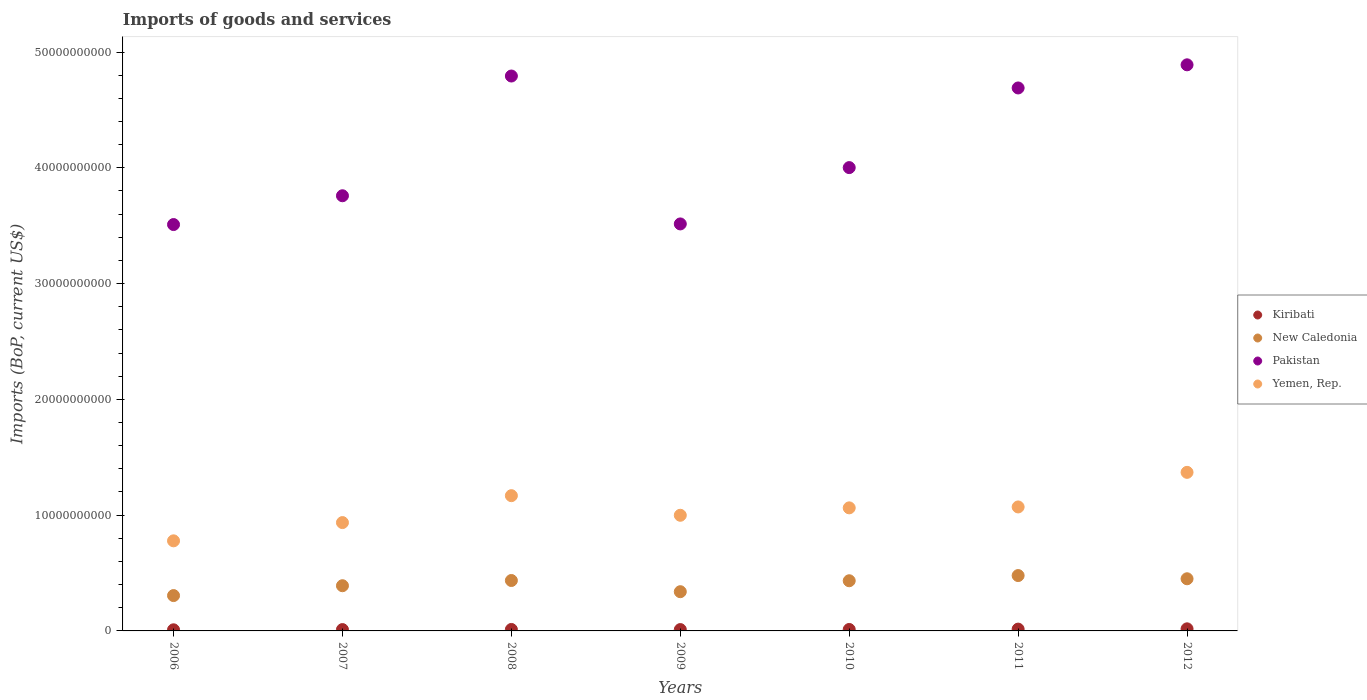Is the number of dotlines equal to the number of legend labels?
Your response must be concise. Yes. What is the amount spent on imports in Kiribati in 2009?
Provide a short and direct response. 1.16e+08. Across all years, what is the maximum amount spent on imports in Yemen, Rep.?
Provide a short and direct response. 1.37e+1. Across all years, what is the minimum amount spent on imports in New Caledonia?
Offer a terse response. 3.05e+09. What is the total amount spent on imports in Yemen, Rep. in the graph?
Your response must be concise. 7.38e+1. What is the difference between the amount spent on imports in New Caledonia in 2008 and that in 2011?
Your answer should be very brief. -4.27e+08. What is the difference between the amount spent on imports in New Caledonia in 2009 and the amount spent on imports in Kiribati in 2012?
Offer a very short reply. 3.21e+09. What is the average amount spent on imports in Pakistan per year?
Provide a succinct answer. 4.17e+1. In the year 2008, what is the difference between the amount spent on imports in Pakistan and amount spent on imports in Kiribati?
Keep it short and to the point. 4.78e+1. What is the ratio of the amount spent on imports in Pakistan in 2008 to that in 2009?
Your answer should be compact. 1.36. Is the difference between the amount spent on imports in Pakistan in 2006 and 2010 greater than the difference between the amount spent on imports in Kiribati in 2006 and 2010?
Provide a short and direct response. No. What is the difference between the highest and the second highest amount spent on imports in Kiribati?
Make the answer very short. 2.43e+07. What is the difference between the highest and the lowest amount spent on imports in Kiribati?
Make the answer very short. 8.41e+07. In how many years, is the amount spent on imports in Kiribati greater than the average amount spent on imports in Kiribati taken over all years?
Offer a terse response. 2. Does the amount spent on imports in Pakistan monotonically increase over the years?
Give a very brief answer. No. Is the amount spent on imports in Pakistan strictly less than the amount spent on imports in Yemen, Rep. over the years?
Your answer should be very brief. No. How many dotlines are there?
Make the answer very short. 4. How many years are there in the graph?
Your response must be concise. 7. Does the graph contain any zero values?
Provide a short and direct response. No. Where does the legend appear in the graph?
Your answer should be very brief. Center right. How many legend labels are there?
Your answer should be compact. 4. How are the legend labels stacked?
Provide a short and direct response. Vertical. What is the title of the graph?
Give a very brief answer. Imports of goods and services. Does "Lesotho" appear as one of the legend labels in the graph?
Your response must be concise. No. What is the label or title of the Y-axis?
Offer a very short reply. Imports (BoP, current US$). What is the Imports (BoP, current US$) in Kiribati in 2006?
Provide a succinct answer. 9.63e+07. What is the Imports (BoP, current US$) in New Caledonia in 2006?
Provide a succinct answer. 3.05e+09. What is the Imports (BoP, current US$) of Pakistan in 2006?
Ensure brevity in your answer.  3.51e+1. What is the Imports (BoP, current US$) of Yemen, Rep. in 2006?
Keep it short and to the point. 7.78e+09. What is the Imports (BoP, current US$) in Kiribati in 2007?
Your response must be concise. 1.16e+08. What is the Imports (BoP, current US$) in New Caledonia in 2007?
Provide a succinct answer. 3.90e+09. What is the Imports (BoP, current US$) of Pakistan in 2007?
Your answer should be compact. 3.76e+1. What is the Imports (BoP, current US$) of Yemen, Rep. in 2007?
Ensure brevity in your answer.  9.36e+09. What is the Imports (BoP, current US$) of Kiribati in 2008?
Provide a short and direct response. 1.26e+08. What is the Imports (BoP, current US$) of New Caledonia in 2008?
Provide a succinct answer. 4.35e+09. What is the Imports (BoP, current US$) in Pakistan in 2008?
Keep it short and to the point. 4.79e+1. What is the Imports (BoP, current US$) of Yemen, Rep. in 2008?
Keep it short and to the point. 1.17e+1. What is the Imports (BoP, current US$) of Kiribati in 2009?
Give a very brief answer. 1.16e+08. What is the Imports (BoP, current US$) in New Caledonia in 2009?
Keep it short and to the point. 3.39e+09. What is the Imports (BoP, current US$) of Pakistan in 2009?
Offer a very short reply. 3.52e+1. What is the Imports (BoP, current US$) in Yemen, Rep. in 2009?
Your response must be concise. 9.99e+09. What is the Imports (BoP, current US$) of Kiribati in 2010?
Offer a very short reply. 1.26e+08. What is the Imports (BoP, current US$) in New Caledonia in 2010?
Your answer should be compact. 4.33e+09. What is the Imports (BoP, current US$) of Pakistan in 2010?
Offer a terse response. 4.00e+1. What is the Imports (BoP, current US$) in Yemen, Rep. in 2010?
Offer a very short reply. 1.06e+1. What is the Imports (BoP, current US$) in Kiribati in 2011?
Provide a succinct answer. 1.56e+08. What is the Imports (BoP, current US$) of New Caledonia in 2011?
Make the answer very short. 4.78e+09. What is the Imports (BoP, current US$) in Pakistan in 2011?
Offer a very short reply. 4.69e+1. What is the Imports (BoP, current US$) of Yemen, Rep. in 2011?
Provide a short and direct response. 1.07e+1. What is the Imports (BoP, current US$) in Kiribati in 2012?
Ensure brevity in your answer.  1.80e+08. What is the Imports (BoP, current US$) of New Caledonia in 2012?
Your answer should be compact. 4.50e+09. What is the Imports (BoP, current US$) of Pakistan in 2012?
Your answer should be compact. 4.89e+1. What is the Imports (BoP, current US$) in Yemen, Rep. in 2012?
Your response must be concise. 1.37e+1. Across all years, what is the maximum Imports (BoP, current US$) of Kiribati?
Your answer should be compact. 1.80e+08. Across all years, what is the maximum Imports (BoP, current US$) of New Caledonia?
Ensure brevity in your answer.  4.78e+09. Across all years, what is the maximum Imports (BoP, current US$) of Pakistan?
Keep it short and to the point. 4.89e+1. Across all years, what is the maximum Imports (BoP, current US$) of Yemen, Rep.?
Offer a terse response. 1.37e+1. Across all years, what is the minimum Imports (BoP, current US$) in Kiribati?
Keep it short and to the point. 9.63e+07. Across all years, what is the minimum Imports (BoP, current US$) in New Caledonia?
Give a very brief answer. 3.05e+09. Across all years, what is the minimum Imports (BoP, current US$) of Pakistan?
Your answer should be compact. 3.51e+1. Across all years, what is the minimum Imports (BoP, current US$) in Yemen, Rep.?
Your answer should be very brief. 7.78e+09. What is the total Imports (BoP, current US$) of Kiribati in the graph?
Provide a succinct answer. 9.16e+08. What is the total Imports (BoP, current US$) of New Caledonia in the graph?
Give a very brief answer. 2.83e+1. What is the total Imports (BoP, current US$) of Pakistan in the graph?
Keep it short and to the point. 2.92e+11. What is the total Imports (BoP, current US$) of Yemen, Rep. in the graph?
Make the answer very short. 7.38e+1. What is the difference between the Imports (BoP, current US$) in Kiribati in 2006 and that in 2007?
Provide a succinct answer. -1.95e+07. What is the difference between the Imports (BoP, current US$) of New Caledonia in 2006 and that in 2007?
Offer a very short reply. -8.51e+08. What is the difference between the Imports (BoP, current US$) of Pakistan in 2006 and that in 2007?
Provide a short and direct response. -2.49e+09. What is the difference between the Imports (BoP, current US$) of Yemen, Rep. in 2006 and that in 2007?
Provide a short and direct response. -1.58e+09. What is the difference between the Imports (BoP, current US$) in Kiribati in 2006 and that in 2008?
Provide a succinct answer. -2.96e+07. What is the difference between the Imports (BoP, current US$) of New Caledonia in 2006 and that in 2008?
Offer a terse response. -1.30e+09. What is the difference between the Imports (BoP, current US$) of Pakistan in 2006 and that in 2008?
Provide a succinct answer. -1.28e+1. What is the difference between the Imports (BoP, current US$) of Yemen, Rep. in 2006 and that in 2008?
Your response must be concise. -3.90e+09. What is the difference between the Imports (BoP, current US$) of Kiribati in 2006 and that in 2009?
Offer a very short reply. -1.99e+07. What is the difference between the Imports (BoP, current US$) of New Caledonia in 2006 and that in 2009?
Offer a very short reply. -3.35e+08. What is the difference between the Imports (BoP, current US$) of Pakistan in 2006 and that in 2009?
Provide a short and direct response. -5.40e+07. What is the difference between the Imports (BoP, current US$) in Yemen, Rep. in 2006 and that in 2009?
Your response must be concise. -2.21e+09. What is the difference between the Imports (BoP, current US$) in Kiribati in 2006 and that in 2010?
Keep it short and to the point. -2.94e+07. What is the difference between the Imports (BoP, current US$) in New Caledonia in 2006 and that in 2010?
Offer a terse response. -1.28e+09. What is the difference between the Imports (BoP, current US$) in Pakistan in 2006 and that in 2010?
Keep it short and to the point. -4.92e+09. What is the difference between the Imports (BoP, current US$) of Yemen, Rep. in 2006 and that in 2010?
Your answer should be very brief. -2.85e+09. What is the difference between the Imports (BoP, current US$) in Kiribati in 2006 and that in 2011?
Provide a short and direct response. -5.98e+07. What is the difference between the Imports (BoP, current US$) in New Caledonia in 2006 and that in 2011?
Provide a short and direct response. -1.73e+09. What is the difference between the Imports (BoP, current US$) in Pakistan in 2006 and that in 2011?
Give a very brief answer. -1.18e+1. What is the difference between the Imports (BoP, current US$) of Yemen, Rep. in 2006 and that in 2011?
Your answer should be compact. -2.93e+09. What is the difference between the Imports (BoP, current US$) of Kiribati in 2006 and that in 2012?
Make the answer very short. -8.41e+07. What is the difference between the Imports (BoP, current US$) of New Caledonia in 2006 and that in 2012?
Ensure brevity in your answer.  -1.45e+09. What is the difference between the Imports (BoP, current US$) in Pakistan in 2006 and that in 2012?
Ensure brevity in your answer.  -1.38e+1. What is the difference between the Imports (BoP, current US$) in Yemen, Rep. in 2006 and that in 2012?
Offer a terse response. -5.91e+09. What is the difference between the Imports (BoP, current US$) in Kiribati in 2007 and that in 2008?
Offer a terse response. -1.01e+07. What is the difference between the Imports (BoP, current US$) in New Caledonia in 2007 and that in 2008?
Provide a short and direct response. -4.51e+08. What is the difference between the Imports (BoP, current US$) in Pakistan in 2007 and that in 2008?
Keep it short and to the point. -1.03e+1. What is the difference between the Imports (BoP, current US$) in Yemen, Rep. in 2007 and that in 2008?
Make the answer very short. -2.32e+09. What is the difference between the Imports (BoP, current US$) of Kiribati in 2007 and that in 2009?
Offer a terse response. -4.05e+05. What is the difference between the Imports (BoP, current US$) of New Caledonia in 2007 and that in 2009?
Give a very brief answer. 5.16e+08. What is the difference between the Imports (BoP, current US$) in Pakistan in 2007 and that in 2009?
Ensure brevity in your answer.  2.43e+09. What is the difference between the Imports (BoP, current US$) of Yemen, Rep. in 2007 and that in 2009?
Offer a terse response. -6.31e+08. What is the difference between the Imports (BoP, current US$) of Kiribati in 2007 and that in 2010?
Provide a succinct answer. -9.92e+06. What is the difference between the Imports (BoP, current US$) of New Caledonia in 2007 and that in 2010?
Your answer should be compact. -4.29e+08. What is the difference between the Imports (BoP, current US$) in Pakistan in 2007 and that in 2010?
Your answer should be very brief. -2.43e+09. What is the difference between the Imports (BoP, current US$) of Yemen, Rep. in 2007 and that in 2010?
Your answer should be very brief. -1.27e+09. What is the difference between the Imports (BoP, current US$) in Kiribati in 2007 and that in 2011?
Provide a short and direct response. -4.03e+07. What is the difference between the Imports (BoP, current US$) of New Caledonia in 2007 and that in 2011?
Offer a very short reply. -8.78e+08. What is the difference between the Imports (BoP, current US$) in Pakistan in 2007 and that in 2011?
Offer a terse response. -9.31e+09. What is the difference between the Imports (BoP, current US$) in Yemen, Rep. in 2007 and that in 2011?
Your answer should be compact. -1.35e+09. What is the difference between the Imports (BoP, current US$) in Kiribati in 2007 and that in 2012?
Give a very brief answer. -6.46e+07. What is the difference between the Imports (BoP, current US$) in New Caledonia in 2007 and that in 2012?
Provide a short and direct response. -6.01e+08. What is the difference between the Imports (BoP, current US$) of Pakistan in 2007 and that in 2012?
Offer a very short reply. -1.13e+1. What is the difference between the Imports (BoP, current US$) of Yemen, Rep. in 2007 and that in 2012?
Provide a short and direct response. -4.34e+09. What is the difference between the Imports (BoP, current US$) of Kiribati in 2008 and that in 2009?
Your answer should be very brief. 9.73e+06. What is the difference between the Imports (BoP, current US$) in New Caledonia in 2008 and that in 2009?
Offer a terse response. 9.67e+08. What is the difference between the Imports (BoP, current US$) in Pakistan in 2008 and that in 2009?
Provide a succinct answer. 1.28e+1. What is the difference between the Imports (BoP, current US$) in Yemen, Rep. in 2008 and that in 2009?
Offer a terse response. 1.69e+09. What is the difference between the Imports (BoP, current US$) of Kiribati in 2008 and that in 2010?
Offer a terse response. 2.10e+05. What is the difference between the Imports (BoP, current US$) of New Caledonia in 2008 and that in 2010?
Provide a short and direct response. 2.13e+07. What is the difference between the Imports (BoP, current US$) in Pakistan in 2008 and that in 2010?
Keep it short and to the point. 7.91e+09. What is the difference between the Imports (BoP, current US$) in Yemen, Rep. in 2008 and that in 2010?
Your response must be concise. 1.05e+09. What is the difference between the Imports (BoP, current US$) in Kiribati in 2008 and that in 2011?
Provide a succinct answer. -3.02e+07. What is the difference between the Imports (BoP, current US$) of New Caledonia in 2008 and that in 2011?
Your answer should be compact. -4.27e+08. What is the difference between the Imports (BoP, current US$) of Pakistan in 2008 and that in 2011?
Your answer should be compact. 1.03e+09. What is the difference between the Imports (BoP, current US$) of Yemen, Rep. in 2008 and that in 2011?
Your answer should be compact. 9.74e+08. What is the difference between the Imports (BoP, current US$) of Kiribati in 2008 and that in 2012?
Offer a terse response. -5.44e+07. What is the difference between the Imports (BoP, current US$) of New Caledonia in 2008 and that in 2012?
Ensure brevity in your answer.  -1.50e+08. What is the difference between the Imports (BoP, current US$) in Pakistan in 2008 and that in 2012?
Your answer should be compact. -9.67e+08. What is the difference between the Imports (BoP, current US$) in Yemen, Rep. in 2008 and that in 2012?
Provide a succinct answer. -2.01e+09. What is the difference between the Imports (BoP, current US$) of Kiribati in 2009 and that in 2010?
Ensure brevity in your answer.  -9.52e+06. What is the difference between the Imports (BoP, current US$) in New Caledonia in 2009 and that in 2010?
Ensure brevity in your answer.  -9.46e+08. What is the difference between the Imports (BoP, current US$) in Pakistan in 2009 and that in 2010?
Give a very brief answer. -4.86e+09. What is the difference between the Imports (BoP, current US$) in Yemen, Rep. in 2009 and that in 2010?
Your response must be concise. -6.41e+08. What is the difference between the Imports (BoP, current US$) in Kiribati in 2009 and that in 2011?
Offer a very short reply. -3.99e+07. What is the difference between the Imports (BoP, current US$) in New Caledonia in 2009 and that in 2011?
Ensure brevity in your answer.  -1.39e+09. What is the difference between the Imports (BoP, current US$) in Pakistan in 2009 and that in 2011?
Give a very brief answer. -1.17e+1. What is the difference between the Imports (BoP, current US$) of Yemen, Rep. in 2009 and that in 2011?
Give a very brief answer. -7.19e+08. What is the difference between the Imports (BoP, current US$) in Kiribati in 2009 and that in 2012?
Give a very brief answer. -6.42e+07. What is the difference between the Imports (BoP, current US$) of New Caledonia in 2009 and that in 2012?
Your answer should be compact. -1.12e+09. What is the difference between the Imports (BoP, current US$) in Pakistan in 2009 and that in 2012?
Ensure brevity in your answer.  -1.37e+1. What is the difference between the Imports (BoP, current US$) in Yemen, Rep. in 2009 and that in 2012?
Your answer should be very brief. -3.71e+09. What is the difference between the Imports (BoP, current US$) in Kiribati in 2010 and that in 2011?
Your answer should be compact. -3.04e+07. What is the difference between the Imports (BoP, current US$) of New Caledonia in 2010 and that in 2011?
Ensure brevity in your answer.  -4.48e+08. What is the difference between the Imports (BoP, current US$) in Pakistan in 2010 and that in 2011?
Make the answer very short. -6.88e+09. What is the difference between the Imports (BoP, current US$) in Yemen, Rep. in 2010 and that in 2011?
Offer a terse response. -7.88e+07. What is the difference between the Imports (BoP, current US$) in Kiribati in 2010 and that in 2012?
Provide a succinct answer. -5.46e+07. What is the difference between the Imports (BoP, current US$) in New Caledonia in 2010 and that in 2012?
Provide a succinct answer. -1.71e+08. What is the difference between the Imports (BoP, current US$) in Pakistan in 2010 and that in 2012?
Keep it short and to the point. -8.88e+09. What is the difference between the Imports (BoP, current US$) in Yemen, Rep. in 2010 and that in 2012?
Offer a very short reply. -3.07e+09. What is the difference between the Imports (BoP, current US$) in Kiribati in 2011 and that in 2012?
Your answer should be compact. -2.43e+07. What is the difference between the Imports (BoP, current US$) in New Caledonia in 2011 and that in 2012?
Your answer should be very brief. 2.77e+08. What is the difference between the Imports (BoP, current US$) of Pakistan in 2011 and that in 2012?
Offer a very short reply. -2.00e+09. What is the difference between the Imports (BoP, current US$) in Yemen, Rep. in 2011 and that in 2012?
Offer a very short reply. -2.99e+09. What is the difference between the Imports (BoP, current US$) in Kiribati in 2006 and the Imports (BoP, current US$) in New Caledonia in 2007?
Ensure brevity in your answer.  -3.81e+09. What is the difference between the Imports (BoP, current US$) in Kiribati in 2006 and the Imports (BoP, current US$) in Pakistan in 2007?
Ensure brevity in your answer.  -3.75e+1. What is the difference between the Imports (BoP, current US$) in Kiribati in 2006 and the Imports (BoP, current US$) in Yemen, Rep. in 2007?
Provide a succinct answer. -9.26e+09. What is the difference between the Imports (BoP, current US$) of New Caledonia in 2006 and the Imports (BoP, current US$) of Pakistan in 2007?
Give a very brief answer. -3.45e+1. What is the difference between the Imports (BoP, current US$) of New Caledonia in 2006 and the Imports (BoP, current US$) of Yemen, Rep. in 2007?
Give a very brief answer. -6.30e+09. What is the difference between the Imports (BoP, current US$) of Pakistan in 2006 and the Imports (BoP, current US$) of Yemen, Rep. in 2007?
Offer a very short reply. 2.57e+1. What is the difference between the Imports (BoP, current US$) of Kiribati in 2006 and the Imports (BoP, current US$) of New Caledonia in 2008?
Your response must be concise. -4.26e+09. What is the difference between the Imports (BoP, current US$) in Kiribati in 2006 and the Imports (BoP, current US$) in Pakistan in 2008?
Provide a succinct answer. -4.78e+1. What is the difference between the Imports (BoP, current US$) of Kiribati in 2006 and the Imports (BoP, current US$) of Yemen, Rep. in 2008?
Give a very brief answer. -1.16e+1. What is the difference between the Imports (BoP, current US$) of New Caledonia in 2006 and the Imports (BoP, current US$) of Pakistan in 2008?
Provide a short and direct response. -4.49e+1. What is the difference between the Imports (BoP, current US$) of New Caledonia in 2006 and the Imports (BoP, current US$) of Yemen, Rep. in 2008?
Offer a very short reply. -8.63e+09. What is the difference between the Imports (BoP, current US$) of Pakistan in 2006 and the Imports (BoP, current US$) of Yemen, Rep. in 2008?
Provide a succinct answer. 2.34e+1. What is the difference between the Imports (BoP, current US$) in Kiribati in 2006 and the Imports (BoP, current US$) in New Caledonia in 2009?
Your answer should be very brief. -3.29e+09. What is the difference between the Imports (BoP, current US$) in Kiribati in 2006 and the Imports (BoP, current US$) in Pakistan in 2009?
Give a very brief answer. -3.51e+1. What is the difference between the Imports (BoP, current US$) of Kiribati in 2006 and the Imports (BoP, current US$) of Yemen, Rep. in 2009?
Your answer should be compact. -9.89e+09. What is the difference between the Imports (BoP, current US$) in New Caledonia in 2006 and the Imports (BoP, current US$) in Pakistan in 2009?
Make the answer very short. -3.21e+1. What is the difference between the Imports (BoP, current US$) of New Caledonia in 2006 and the Imports (BoP, current US$) of Yemen, Rep. in 2009?
Your answer should be very brief. -6.94e+09. What is the difference between the Imports (BoP, current US$) of Pakistan in 2006 and the Imports (BoP, current US$) of Yemen, Rep. in 2009?
Keep it short and to the point. 2.51e+1. What is the difference between the Imports (BoP, current US$) in Kiribati in 2006 and the Imports (BoP, current US$) in New Caledonia in 2010?
Give a very brief answer. -4.24e+09. What is the difference between the Imports (BoP, current US$) of Kiribati in 2006 and the Imports (BoP, current US$) of Pakistan in 2010?
Provide a succinct answer. -3.99e+1. What is the difference between the Imports (BoP, current US$) of Kiribati in 2006 and the Imports (BoP, current US$) of Yemen, Rep. in 2010?
Your response must be concise. -1.05e+1. What is the difference between the Imports (BoP, current US$) in New Caledonia in 2006 and the Imports (BoP, current US$) in Pakistan in 2010?
Your response must be concise. -3.70e+1. What is the difference between the Imports (BoP, current US$) in New Caledonia in 2006 and the Imports (BoP, current US$) in Yemen, Rep. in 2010?
Offer a very short reply. -7.58e+09. What is the difference between the Imports (BoP, current US$) in Pakistan in 2006 and the Imports (BoP, current US$) in Yemen, Rep. in 2010?
Ensure brevity in your answer.  2.45e+1. What is the difference between the Imports (BoP, current US$) of Kiribati in 2006 and the Imports (BoP, current US$) of New Caledonia in 2011?
Offer a terse response. -4.69e+09. What is the difference between the Imports (BoP, current US$) in Kiribati in 2006 and the Imports (BoP, current US$) in Pakistan in 2011?
Offer a terse response. -4.68e+1. What is the difference between the Imports (BoP, current US$) in Kiribati in 2006 and the Imports (BoP, current US$) in Yemen, Rep. in 2011?
Offer a very short reply. -1.06e+1. What is the difference between the Imports (BoP, current US$) in New Caledonia in 2006 and the Imports (BoP, current US$) in Pakistan in 2011?
Provide a short and direct response. -4.38e+1. What is the difference between the Imports (BoP, current US$) of New Caledonia in 2006 and the Imports (BoP, current US$) of Yemen, Rep. in 2011?
Offer a very short reply. -7.66e+09. What is the difference between the Imports (BoP, current US$) in Pakistan in 2006 and the Imports (BoP, current US$) in Yemen, Rep. in 2011?
Keep it short and to the point. 2.44e+1. What is the difference between the Imports (BoP, current US$) in Kiribati in 2006 and the Imports (BoP, current US$) in New Caledonia in 2012?
Offer a terse response. -4.41e+09. What is the difference between the Imports (BoP, current US$) in Kiribati in 2006 and the Imports (BoP, current US$) in Pakistan in 2012?
Keep it short and to the point. -4.88e+1. What is the difference between the Imports (BoP, current US$) of Kiribati in 2006 and the Imports (BoP, current US$) of Yemen, Rep. in 2012?
Your answer should be very brief. -1.36e+1. What is the difference between the Imports (BoP, current US$) in New Caledonia in 2006 and the Imports (BoP, current US$) in Pakistan in 2012?
Offer a terse response. -4.58e+1. What is the difference between the Imports (BoP, current US$) of New Caledonia in 2006 and the Imports (BoP, current US$) of Yemen, Rep. in 2012?
Give a very brief answer. -1.06e+1. What is the difference between the Imports (BoP, current US$) of Pakistan in 2006 and the Imports (BoP, current US$) of Yemen, Rep. in 2012?
Your response must be concise. 2.14e+1. What is the difference between the Imports (BoP, current US$) of Kiribati in 2007 and the Imports (BoP, current US$) of New Caledonia in 2008?
Provide a succinct answer. -4.24e+09. What is the difference between the Imports (BoP, current US$) in Kiribati in 2007 and the Imports (BoP, current US$) in Pakistan in 2008?
Provide a succinct answer. -4.78e+1. What is the difference between the Imports (BoP, current US$) in Kiribati in 2007 and the Imports (BoP, current US$) in Yemen, Rep. in 2008?
Ensure brevity in your answer.  -1.16e+1. What is the difference between the Imports (BoP, current US$) of New Caledonia in 2007 and the Imports (BoP, current US$) of Pakistan in 2008?
Keep it short and to the point. -4.40e+1. What is the difference between the Imports (BoP, current US$) in New Caledonia in 2007 and the Imports (BoP, current US$) in Yemen, Rep. in 2008?
Provide a short and direct response. -7.78e+09. What is the difference between the Imports (BoP, current US$) of Pakistan in 2007 and the Imports (BoP, current US$) of Yemen, Rep. in 2008?
Provide a succinct answer. 2.59e+1. What is the difference between the Imports (BoP, current US$) in Kiribati in 2007 and the Imports (BoP, current US$) in New Caledonia in 2009?
Provide a succinct answer. -3.27e+09. What is the difference between the Imports (BoP, current US$) of Kiribati in 2007 and the Imports (BoP, current US$) of Pakistan in 2009?
Your answer should be compact. -3.50e+1. What is the difference between the Imports (BoP, current US$) in Kiribati in 2007 and the Imports (BoP, current US$) in Yemen, Rep. in 2009?
Your answer should be compact. -9.87e+09. What is the difference between the Imports (BoP, current US$) in New Caledonia in 2007 and the Imports (BoP, current US$) in Pakistan in 2009?
Your answer should be compact. -3.12e+1. What is the difference between the Imports (BoP, current US$) of New Caledonia in 2007 and the Imports (BoP, current US$) of Yemen, Rep. in 2009?
Offer a very short reply. -6.08e+09. What is the difference between the Imports (BoP, current US$) in Pakistan in 2007 and the Imports (BoP, current US$) in Yemen, Rep. in 2009?
Your response must be concise. 2.76e+1. What is the difference between the Imports (BoP, current US$) of Kiribati in 2007 and the Imports (BoP, current US$) of New Caledonia in 2010?
Provide a short and direct response. -4.22e+09. What is the difference between the Imports (BoP, current US$) in Kiribati in 2007 and the Imports (BoP, current US$) in Pakistan in 2010?
Your answer should be very brief. -3.99e+1. What is the difference between the Imports (BoP, current US$) of Kiribati in 2007 and the Imports (BoP, current US$) of Yemen, Rep. in 2010?
Your answer should be very brief. -1.05e+1. What is the difference between the Imports (BoP, current US$) of New Caledonia in 2007 and the Imports (BoP, current US$) of Pakistan in 2010?
Offer a terse response. -3.61e+1. What is the difference between the Imports (BoP, current US$) in New Caledonia in 2007 and the Imports (BoP, current US$) in Yemen, Rep. in 2010?
Provide a short and direct response. -6.73e+09. What is the difference between the Imports (BoP, current US$) of Pakistan in 2007 and the Imports (BoP, current US$) of Yemen, Rep. in 2010?
Make the answer very short. 2.70e+1. What is the difference between the Imports (BoP, current US$) in Kiribati in 2007 and the Imports (BoP, current US$) in New Caledonia in 2011?
Your answer should be very brief. -4.67e+09. What is the difference between the Imports (BoP, current US$) of Kiribati in 2007 and the Imports (BoP, current US$) of Pakistan in 2011?
Provide a succinct answer. -4.68e+1. What is the difference between the Imports (BoP, current US$) in Kiribati in 2007 and the Imports (BoP, current US$) in Yemen, Rep. in 2011?
Your answer should be very brief. -1.06e+1. What is the difference between the Imports (BoP, current US$) of New Caledonia in 2007 and the Imports (BoP, current US$) of Pakistan in 2011?
Your answer should be very brief. -4.30e+1. What is the difference between the Imports (BoP, current US$) in New Caledonia in 2007 and the Imports (BoP, current US$) in Yemen, Rep. in 2011?
Give a very brief answer. -6.80e+09. What is the difference between the Imports (BoP, current US$) in Pakistan in 2007 and the Imports (BoP, current US$) in Yemen, Rep. in 2011?
Provide a short and direct response. 2.69e+1. What is the difference between the Imports (BoP, current US$) of Kiribati in 2007 and the Imports (BoP, current US$) of New Caledonia in 2012?
Ensure brevity in your answer.  -4.39e+09. What is the difference between the Imports (BoP, current US$) in Kiribati in 2007 and the Imports (BoP, current US$) in Pakistan in 2012?
Provide a succinct answer. -4.88e+1. What is the difference between the Imports (BoP, current US$) of Kiribati in 2007 and the Imports (BoP, current US$) of Yemen, Rep. in 2012?
Your answer should be compact. -1.36e+1. What is the difference between the Imports (BoP, current US$) in New Caledonia in 2007 and the Imports (BoP, current US$) in Pakistan in 2012?
Give a very brief answer. -4.50e+1. What is the difference between the Imports (BoP, current US$) in New Caledonia in 2007 and the Imports (BoP, current US$) in Yemen, Rep. in 2012?
Provide a succinct answer. -9.79e+09. What is the difference between the Imports (BoP, current US$) in Pakistan in 2007 and the Imports (BoP, current US$) in Yemen, Rep. in 2012?
Give a very brief answer. 2.39e+1. What is the difference between the Imports (BoP, current US$) in Kiribati in 2008 and the Imports (BoP, current US$) in New Caledonia in 2009?
Keep it short and to the point. -3.26e+09. What is the difference between the Imports (BoP, current US$) of Kiribati in 2008 and the Imports (BoP, current US$) of Pakistan in 2009?
Your response must be concise. -3.50e+1. What is the difference between the Imports (BoP, current US$) of Kiribati in 2008 and the Imports (BoP, current US$) of Yemen, Rep. in 2009?
Ensure brevity in your answer.  -9.86e+09. What is the difference between the Imports (BoP, current US$) of New Caledonia in 2008 and the Imports (BoP, current US$) of Pakistan in 2009?
Ensure brevity in your answer.  -3.08e+1. What is the difference between the Imports (BoP, current US$) of New Caledonia in 2008 and the Imports (BoP, current US$) of Yemen, Rep. in 2009?
Your answer should be compact. -5.63e+09. What is the difference between the Imports (BoP, current US$) of Pakistan in 2008 and the Imports (BoP, current US$) of Yemen, Rep. in 2009?
Keep it short and to the point. 3.79e+1. What is the difference between the Imports (BoP, current US$) in Kiribati in 2008 and the Imports (BoP, current US$) in New Caledonia in 2010?
Your answer should be compact. -4.21e+09. What is the difference between the Imports (BoP, current US$) of Kiribati in 2008 and the Imports (BoP, current US$) of Pakistan in 2010?
Ensure brevity in your answer.  -3.99e+1. What is the difference between the Imports (BoP, current US$) in Kiribati in 2008 and the Imports (BoP, current US$) in Yemen, Rep. in 2010?
Ensure brevity in your answer.  -1.05e+1. What is the difference between the Imports (BoP, current US$) in New Caledonia in 2008 and the Imports (BoP, current US$) in Pakistan in 2010?
Your answer should be compact. -3.57e+1. What is the difference between the Imports (BoP, current US$) of New Caledonia in 2008 and the Imports (BoP, current US$) of Yemen, Rep. in 2010?
Make the answer very short. -6.27e+09. What is the difference between the Imports (BoP, current US$) of Pakistan in 2008 and the Imports (BoP, current US$) of Yemen, Rep. in 2010?
Offer a terse response. 3.73e+1. What is the difference between the Imports (BoP, current US$) of Kiribati in 2008 and the Imports (BoP, current US$) of New Caledonia in 2011?
Keep it short and to the point. -4.66e+09. What is the difference between the Imports (BoP, current US$) in Kiribati in 2008 and the Imports (BoP, current US$) in Pakistan in 2011?
Your answer should be very brief. -4.68e+1. What is the difference between the Imports (BoP, current US$) of Kiribati in 2008 and the Imports (BoP, current US$) of Yemen, Rep. in 2011?
Your answer should be compact. -1.06e+1. What is the difference between the Imports (BoP, current US$) of New Caledonia in 2008 and the Imports (BoP, current US$) of Pakistan in 2011?
Provide a succinct answer. -4.25e+1. What is the difference between the Imports (BoP, current US$) of New Caledonia in 2008 and the Imports (BoP, current US$) of Yemen, Rep. in 2011?
Your response must be concise. -6.35e+09. What is the difference between the Imports (BoP, current US$) in Pakistan in 2008 and the Imports (BoP, current US$) in Yemen, Rep. in 2011?
Make the answer very short. 3.72e+1. What is the difference between the Imports (BoP, current US$) in Kiribati in 2008 and the Imports (BoP, current US$) in New Caledonia in 2012?
Your answer should be very brief. -4.38e+09. What is the difference between the Imports (BoP, current US$) in Kiribati in 2008 and the Imports (BoP, current US$) in Pakistan in 2012?
Provide a short and direct response. -4.88e+1. What is the difference between the Imports (BoP, current US$) of Kiribati in 2008 and the Imports (BoP, current US$) of Yemen, Rep. in 2012?
Offer a very short reply. -1.36e+1. What is the difference between the Imports (BoP, current US$) in New Caledonia in 2008 and the Imports (BoP, current US$) in Pakistan in 2012?
Give a very brief answer. -4.45e+1. What is the difference between the Imports (BoP, current US$) of New Caledonia in 2008 and the Imports (BoP, current US$) of Yemen, Rep. in 2012?
Make the answer very short. -9.34e+09. What is the difference between the Imports (BoP, current US$) in Pakistan in 2008 and the Imports (BoP, current US$) in Yemen, Rep. in 2012?
Make the answer very short. 3.42e+1. What is the difference between the Imports (BoP, current US$) in Kiribati in 2009 and the Imports (BoP, current US$) in New Caledonia in 2010?
Your answer should be very brief. -4.22e+09. What is the difference between the Imports (BoP, current US$) of Kiribati in 2009 and the Imports (BoP, current US$) of Pakistan in 2010?
Give a very brief answer. -3.99e+1. What is the difference between the Imports (BoP, current US$) of Kiribati in 2009 and the Imports (BoP, current US$) of Yemen, Rep. in 2010?
Offer a terse response. -1.05e+1. What is the difference between the Imports (BoP, current US$) of New Caledonia in 2009 and the Imports (BoP, current US$) of Pakistan in 2010?
Give a very brief answer. -3.66e+1. What is the difference between the Imports (BoP, current US$) in New Caledonia in 2009 and the Imports (BoP, current US$) in Yemen, Rep. in 2010?
Keep it short and to the point. -7.24e+09. What is the difference between the Imports (BoP, current US$) in Pakistan in 2009 and the Imports (BoP, current US$) in Yemen, Rep. in 2010?
Ensure brevity in your answer.  2.45e+1. What is the difference between the Imports (BoP, current US$) of Kiribati in 2009 and the Imports (BoP, current US$) of New Caledonia in 2011?
Your answer should be compact. -4.67e+09. What is the difference between the Imports (BoP, current US$) of Kiribati in 2009 and the Imports (BoP, current US$) of Pakistan in 2011?
Your answer should be compact. -4.68e+1. What is the difference between the Imports (BoP, current US$) in Kiribati in 2009 and the Imports (BoP, current US$) in Yemen, Rep. in 2011?
Your answer should be compact. -1.06e+1. What is the difference between the Imports (BoP, current US$) in New Caledonia in 2009 and the Imports (BoP, current US$) in Pakistan in 2011?
Your answer should be very brief. -4.35e+1. What is the difference between the Imports (BoP, current US$) of New Caledonia in 2009 and the Imports (BoP, current US$) of Yemen, Rep. in 2011?
Make the answer very short. -7.32e+09. What is the difference between the Imports (BoP, current US$) in Pakistan in 2009 and the Imports (BoP, current US$) in Yemen, Rep. in 2011?
Make the answer very short. 2.44e+1. What is the difference between the Imports (BoP, current US$) in Kiribati in 2009 and the Imports (BoP, current US$) in New Caledonia in 2012?
Your response must be concise. -4.39e+09. What is the difference between the Imports (BoP, current US$) of Kiribati in 2009 and the Imports (BoP, current US$) of Pakistan in 2012?
Your answer should be very brief. -4.88e+1. What is the difference between the Imports (BoP, current US$) of Kiribati in 2009 and the Imports (BoP, current US$) of Yemen, Rep. in 2012?
Offer a very short reply. -1.36e+1. What is the difference between the Imports (BoP, current US$) in New Caledonia in 2009 and the Imports (BoP, current US$) in Pakistan in 2012?
Your response must be concise. -4.55e+1. What is the difference between the Imports (BoP, current US$) in New Caledonia in 2009 and the Imports (BoP, current US$) in Yemen, Rep. in 2012?
Provide a short and direct response. -1.03e+1. What is the difference between the Imports (BoP, current US$) of Pakistan in 2009 and the Imports (BoP, current US$) of Yemen, Rep. in 2012?
Offer a terse response. 2.15e+1. What is the difference between the Imports (BoP, current US$) in Kiribati in 2010 and the Imports (BoP, current US$) in New Caledonia in 2011?
Your answer should be compact. -4.66e+09. What is the difference between the Imports (BoP, current US$) in Kiribati in 2010 and the Imports (BoP, current US$) in Pakistan in 2011?
Make the answer very short. -4.68e+1. What is the difference between the Imports (BoP, current US$) in Kiribati in 2010 and the Imports (BoP, current US$) in Yemen, Rep. in 2011?
Offer a terse response. -1.06e+1. What is the difference between the Imports (BoP, current US$) of New Caledonia in 2010 and the Imports (BoP, current US$) of Pakistan in 2011?
Offer a very short reply. -4.26e+1. What is the difference between the Imports (BoP, current US$) in New Caledonia in 2010 and the Imports (BoP, current US$) in Yemen, Rep. in 2011?
Ensure brevity in your answer.  -6.37e+09. What is the difference between the Imports (BoP, current US$) of Pakistan in 2010 and the Imports (BoP, current US$) of Yemen, Rep. in 2011?
Keep it short and to the point. 2.93e+1. What is the difference between the Imports (BoP, current US$) in Kiribati in 2010 and the Imports (BoP, current US$) in New Caledonia in 2012?
Offer a very short reply. -4.38e+09. What is the difference between the Imports (BoP, current US$) of Kiribati in 2010 and the Imports (BoP, current US$) of Pakistan in 2012?
Ensure brevity in your answer.  -4.88e+1. What is the difference between the Imports (BoP, current US$) in Kiribati in 2010 and the Imports (BoP, current US$) in Yemen, Rep. in 2012?
Offer a very short reply. -1.36e+1. What is the difference between the Imports (BoP, current US$) in New Caledonia in 2010 and the Imports (BoP, current US$) in Pakistan in 2012?
Your answer should be compact. -4.46e+1. What is the difference between the Imports (BoP, current US$) in New Caledonia in 2010 and the Imports (BoP, current US$) in Yemen, Rep. in 2012?
Provide a succinct answer. -9.36e+09. What is the difference between the Imports (BoP, current US$) of Pakistan in 2010 and the Imports (BoP, current US$) of Yemen, Rep. in 2012?
Ensure brevity in your answer.  2.63e+1. What is the difference between the Imports (BoP, current US$) of Kiribati in 2011 and the Imports (BoP, current US$) of New Caledonia in 2012?
Offer a very short reply. -4.35e+09. What is the difference between the Imports (BoP, current US$) in Kiribati in 2011 and the Imports (BoP, current US$) in Pakistan in 2012?
Your answer should be very brief. -4.87e+1. What is the difference between the Imports (BoP, current US$) in Kiribati in 2011 and the Imports (BoP, current US$) in Yemen, Rep. in 2012?
Your answer should be very brief. -1.35e+1. What is the difference between the Imports (BoP, current US$) in New Caledonia in 2011 and the Imports (BoP, current US$) in Pakistan in 2012?
Your response must be concise. -4.41e+1. What is the difference between the Imports (BoP, current US$) in New Caledonia in 2011 and the Imports (BoP, current US$) in Yemen, Rep. in 2012?
Your answer should be very brief. -8.91e+09. What is the difference between the Imports (BoP, current US$) in Pakistan in 2011 and the Imports (BoP, current US$) in Yemen, Rep. in 2012?
Your answer should be compact. 3.32e+1. What is the average Imports (BoP, current US$) in Kiribati per year?
Make the answer very short. 1.31e+08. What is the average Imports (BoP, current US$) in New Caledonia per year?
Offer a terse response. 4.05e+09. What is the average Imports (BoP, current US$) of Pakistan per year?
Make the answer very short. 4.17e+1. What is the average Imports (BoP, current US$) in Yemen, Rep. per year?
Provide a succinct answer. 1.05e+1. In the year 2006, what is the difference between the Imports (BoP, current US$) in Kiribati and Imports (BoP, current US$) in New Caledonia?
Make the answer very short. -2.96e+09. In the year 2006, what is the difference between the Imports (BoP, current US$) in Kiribati and Imports (BoP, current US$) in Pakistan?
Make the answer very short. -3.50e+1. In the year 2006, what is the difference between the Imports (BoP, current US$) in Kiribati and Imports (BoP, current US$) in Yemen, Rep.?
Your answer should be very brief. -7.68e+09. In the year 2006, what is the difference between the Imports (BoP, current US$) in New Caledonia and Imports (BoP, current US$) in Pakistan?
Give a very brief answer. -3.20e+1. In the year 2006, what is the difference between the Imports (BoP, current US$) in New Caledonia and Imports (BoP, current US$) in Yemen, Rep.?
Your answer should be compact. -4.73e+09. In the year 2006, what is the difference between the Imports (BoP, current US$) of Pakistan and Imports (BoP, current US$) of Yemen, Rep.?
Offer a very short reply. 2.73e+1. In the year 2007, what is the difference between the Imports (BoP, current US$) of Kiribati and Imports (BoP, current US$) of New Caledonia?
Your answer should be compact. -3.79e+09. In the year 2007, what is the difference between the Imports (BoP, current US$) in Kiribati and Imports (BoP, current US$) in Pakistan?
Keep it short and to the point. -3.75e+1. In the year 2007, what is the difference between the Imports (BoP, current US$) in Kiribati and Imports (BoP, current US$) in Yemen, Rep.?
Make the answer very short. -9.24e+09. In the year 2007, what is the difference between the Imports (BoP, current US$) in New Caledonia and Imports (BoP, current US$) in Pakistan?
Your answer should be very brief. -3.37e+1. In the year 2007, what is the difference between the Imports (BoP, current US$) in New Caledonia and Imports (BoP, current US$) in Yemen, Rep.?
Ensure brevity in your answer.  -5.45e+09. In the year 2007, what is the difference between the Imports (BoP, current US$) of Pakistan and Imports (BoP, current US$) of Yemen, Rep.?
Provide a succinct answer. 2.82e+1. In the year 2008, what is the difference between the Imports (BoP, current US$) in Kiribati and Imports (BoP, current US$) in New Caledonia?
Ensure brevity in your answer.  -4.23e+09. In the year 2008, what is the difference between the Imports (BoP, current US$) of Kiribati and Imports (BoP, current US$) of Pakistan?
Offer a terse response. -4.78e+1. In the year 2008, what is the difference between the Imports (BoP, current US$) of Kiribati and Imports (BoP, current US$) of Yemen, Rep.?
Ensure brevity in your answer.  -1.16e+1. In the year 2008, what is the difference between the Imports (BoP, current US$) of New Caledonia and Imports (BoP, current US$) of Pakistan?
Give a very brief answer. -4.36e+1. In the year 2008, what is the difference between the Imports (BoP, current US$) in New Caledonia and Imports (BoP, current US$) in Yemen, Rep.?
Ensure brevity in your answer.  -7.33e+09. In the year 2008, what is the difference between the Imports (BoP, current US$) in Pakistan and Imports (BoP, current US$) in Yemen, Rep.?
Your response must be concise. 3.62e+1. In the year 2009, what is the difference between the Imports (BoP, current US$) in Kiribati and Imports (BoP, current US$) in New Caledonia?
Your answer should be very brief. -3.27e+09. In the year 2009, what is the difference between the Imports (BoP, current US$) in Kiribati and Imports (BoP, current US$) in Pakistan?
Your answer should be compact. -3.50e+1. In the year 2009, what is the difference between the Imports (BoP, current US$) of Kiribati and Imports (BoP, current US$) of Yemen, Rep.?
Offer a very short reply. -9.87e+09. In the year 2009, what is the difference between the Imports (BoP, current US$) in New Caledonia and Imports (BoP, current US$) in Pakistan?
Make the answer very short. -3.18e+1. In the year 2009, what is the difference between the Imports (BoP, current US$) in New Caledonia and Imports (BoP, current US$) in Yemen, Rep.?
Give a very brief answer. -6.60e+09. In the year 2009, what is the difference between the Imports (BoP, current US$) in Pakistan and Imports (BoP, current US$) in Yemen, Rep.?
Your answer should be compact. 2.52e+1. In the year 2010, what is the difference between the Imports (BoP, current US$) in Kiribati and Imports (BoP, current US$) in New Caledonia?
Give a very brief answer. -4.21e+09. In the year 2010, what is the difference between the Imports (BoP, current US$) of Kiribati and Imports (BoP, current US$) of Pakistan?
Give a very brief answer. -3.99e+1. In the year 2010, what is the difference between the Imports (BoP, current US$) of Kiribati and Imports (BoP, current US$) of Yemen, Rep.?
Your response must be concise. -1.05e+1. In the year 2010, what is the difference between the Imports (BoP, current US$) of New Caledonia and Imports (BoP, current US$) of Pakistan?
Your response must be concise. -3.57e+1. In the year 2010, what is the difference between the Imports (BoP, current US$) of New Caledonia and Imports (BoP, current US$) of Yemen, Rep.?
Give a very brief answer. -6.30e+09. In the year 2010, what is the difference between the Imports (BoP, current US$) in Pakistan and Imports (BoP, current US$) in Yemen, Rep.?
Your response must be concise. 2.94e+1. In the year 2011, what is the difference between the Imports (BoP, current US$) in Kiribati and Imports (BoP, current US$) in New Caledonia?
Give a very brief answer. -4.63e+09. In the year 2011, what is the difference between the Imports (BoP, current US$) of Kiribati and Imports (BoP, current US$) of Pakistan?
Make the answer very short. -4.67e+1. In the year 2011, what is the difference between the Imports (BoP, current US$) of Kiribati and Imports (BoP, current US$) of Yemen, Rep.?
Offer a terse response. -1.06e+1. In the year 2011, what is the difference between the Imports (BoP, current US$) in New Caledonia and Imports (BoP, current US$) in Pakistan?
Provide a short and direct response. -4.21e+1. In the year 2011, what is the difference between the Imports (BoP, current US$) in New Caledonia and Imports (BoP, current US$) in Yemen, Rep.?
Your answer should be very brief. -5.93e+09. In the year 2011, what is the difference between the Imports (BoP, current US$) of Pakistan and Imports (BoP, current US$) of Yemen, Rep.?
Offer a terse response. 3.62e+1. In the year 2012, what is the difference between the Imports (BoP, current US$) of Kiribati and Imports (BoP, current US$) of New Caledonia?
Provide a succinct answer. -4.32e+09. In the year 2012, what is the difference between the Imports (BoP, current US$) in Kiribati and Imports (BoP, current US$) in Pakistan?
Keep it short and to the point. -4.87e+1. In the year 2012, what is the difference between the Imports (BoP, current US$) in Kiribati and Imports (BoP, current US$) in Yemen, Rep.?
Your response must be concise. -1.35e+1. In the year 2012, what is the difference between the Imports (BoP, current US$) of New Caledonia and Imports (BoP, current US$) of Pakistan?
Provide a succinct answer. -4.44e+1. In the year 2012, what is the difference between the Imports (BoP, current US$) of New Caledonia and Imports (BoP, current US$) of Yemen, Rep.?
Offer a terse response. -9.19e+09. In the year 2012, what is the difference between the Imports (BoP, current US$) of Pakistan and Imports (BoP, current US$) of Yemen, Rep.?
Your response must be concise. 3.52e+1. What is the ratio of the Imports (BoP, current US$) in Kiribati in 2006 to that in 2007?
Make the answer very short. 0.83. What is the ratio of the Imports (BoP, current US$) in New Caledonia in 2006 to that in 2007?
Your answer should be very brief. 0.78. What is the ratio of the Imports (BoP, current US$) in Pakistan in 2006 to that in 2007?
Your response must be concise. 0.93. What is the ratio of the Imports (BoP, current US$) in Yemen, Rep. in 2006 to that in 2007?
Offer a very short reply. 0.83. What is the ratio of the Imports (BoP, current US$) of Kiribati in 2006 to that in 2008?
Your answer should be very brief. 0.76. What is the ratio of the Imports (BoP, current US$) of New Caledonia in 2006 to that in 2008?
Your response must be concise. 0.7. What is the ratio of the Imports (BoP, current US$) in Pakistan in 2006 to that in 2008?
Offer a terse response. 0.73. What is the ratio of the Imports (BoP, current US$) in Yemen, Rep. in 2006 to that in 2008?
Ensure brevity in your answer.  0.67. What is the ratio of the Imports (BoP, current US$) in Kiribati in 2006 to that in 2009?
Make the answer very short. 0.83. What is the ratio of the Imports (BoP, current US$) of New Caledonia in 2006 to that in 2009?
Ensure brevity in your answer.  0.9. What is the ratio of the Imports (BoP, current US$) in Yemen, Rep. in 2006 to that in 2009?
Offer a terse response. 0.78. What is the ratio of the Imports (BoP, current US$) in Kiribati in 2006 to that in 2010?
Give a very brief answer. 0.77. What is the ratio of the Imports (BoP, current US$) in New Caledonia in 2006 to that in 2010?
Provide a succinct answer. 0.7. What is the ratio of the Imports (BoP, current US$) in Pakistan in 2006 to that in 2010?
Make the answer very short. 0.88. What is the ratio of the Imports (BoP, current US$) in Yemen, Rep. in 2006 to that in 2010?
Make the answer very short. 0.73. What is the ratio of the Imports (BoP, current US$) of Kiribati in 2006 to that in 2011?
Your answer should be very brief. 0.62. What is the ratio of the Imports (BoP, current US$) of New Caledonia in 2006 to that in 2011?
Ensure brevity in your answer.  0.64. What is the ratio of the Imports (BoP, current US$) of Pakistan in 2006 to that in 2011?
Your answer should be very brief. 0.75. What is the ratio of the Imports (BoP, current US$) of Yemen, Rep. in 2006 to that in 2011?
Provide a succinct answer. 0.73. What is the ratio of the Imports (BoP, current US$) in Kiribati in 2006 to that in 2012?
Provide a succinct answer. 0.53. What is the ratio of the Imports (BoP, current US$) of New Caledonia in 2006 to that in 2012?
Provide a short and direct response. 0.68. What is the ratio of the Imports (BoP, current US$) in Pakistan in 2006 to that in 2012?
Give a very brief answer. 0.72. What is the ratio of the Imports (BoP, current US$) of Yemen, Rep. in 2006 to that in 2012?
Provide a short and direct response. 0.57. What is the ratio of the Imports (BoP, current US$) of Kiribati in 2007 to that in 2008?
Make the answer very short. 0.92. What is the ratio of the Imports (BoP, current US$) of New Caledonia in 2007 to that in 2008?
Keep it short and to the point. 0.9. What is the ratio of the Imports (BoP, current US$) in Pakistan in 2007 to that in 2008?
Your answer should be very brief. 0.78. What is the ratio of the Imports (BoP, current US$) of Yemen, Rep. in 2007 to that in 2008?
Keep it short and to the point. 0.8. What is the ratio of the Imports (BoP, current US$) in Kiribati in 2007 to that in 2009?
Give a very brief answer. 1. What is the ratio of the Imports (BoP, current US$) in New Caledonia in 2007 to that in 2009?
Ensure brevity in your answer.  1.15. What is the ratio of the Imports (BoP, current US$) in Pakistan in 2007 to that in 2009?
Offer a terse response. 1.07. What is the ratio of the Imports (BoP, current US$) of Yemen, Rep. in 2007 to that in 2009?
Make the answer very short. 0.94. What is the ratio of the Imports (BoP, current US$) of Kiribati in 2007 to that in 2010?
Offer a very short reply. 0.92. What is the ratio of the Imports (BoP, current US$) of New Caledonia in 2007 to that in 2010?
Your response must be concise. 0.9. What is the ratio of the Imports (BoP, current US$) in Pakistan in 2007 to that in 2010?
Offer a very short reply. 0.94. What is the ratio of the Imports (BoP, current US$) in Yemen, Rep. in 2007 to that in 2010?
Give a very brief answer. 0.88. What is the ratio of the Imports (BoP, current US$) of Kiribati in 2007 to that in 2011?
Provide a short and direct response. 0.74. What is the ratio of the Imports (BoP, current US$) of New Caledonia in 2007 to that in 2011?
Keep it short and to the point. 0.82. What is the ratio of the Imports (BoP, current US$) of Pakistan in 2007 to that in 2011?
Give a very brief answer. 0.8. What is the ratio of the Imports (BoP, current US$) of Yemen, Rep. in 2007 to that in 2011?
Offer a terse response. 0.87. What is the ratio of the Imports (BoP, current US$) of Kiribati in 2007 to that in 2012?
Your response must be concise. 0.64. What is the ratio of the Imports (BoP, current US$) in New Caledonia in 2007 to that in 2012?
Offer a terse response. 0.87. What is the ratio of the Imports (BoP, current US$) in Pakistan in 2007 to that in 2012?
Your answer should be compact. 0.77. What is the ratio of the Imports (BoP, current US$) in Yemen, Rep. in 2007 to that in 2012?
Your answer should be compact. 0.68. What is the ratio of the Imports (BoP, current US$) of Kiribati in 2008 to that in 2009?
Ensure brevity in your answer.  1.08. What is the ratio of the Imports (BoP, current US$) of New Caledonia in 2008 to that in 2009?
Ensure brevity in your answer.  1.29. What is the ratio of the Imports (BoP, current US$) of Pakistan in 2008 to that in 2009?
Offer a very short reply. 1.36. What is the ratio of the Imports (BoP, current US$) of Yemen, Rep. in 2008 to that in 2009?
Make the answer very short. 1.17. What is the ratio of the Imports (BoP, current US$) of Kiribati in 2008 to that in 2010?
Keep it short and to the point. 1. What is the ratio of the Imports (BoP, current US$) of Pakistan in 2008 to that in 2010?
Offer a very short reply. 1.2. What is the ratio of the Imports (BoP, current US$) of Yemen, Rep. in 2008 to that in 2010?
Give a very brief answer. 1.1. What is the ratio of the Imports (BoP, current US$) in Kiribati in 2008 to that in 2011?
Provide a short and direct response. 0.81. What is the ratio of the Imports (BoP, current US$) in New Caledonia in 2008 to that in 2011?
Keep it short and to the point. 0.91. What is the ratio of the Imports (BoP, current US$) in Kiribati in 2008 to that in 2012?
Offer a terse response. 0.7. What is the ratio of the Imports (BoP, current US$) in New Caledonia in 2008 to that in 2012?
Ensure brevity in your answer.  0.97. What is the ratio of the Imports (BoP, current US$) in Pakistan in 2008 to that in 2012?
Provide a short and direct response. 0.98. What is the ratio of the Imports (BoP, current US$) of Yemen, Rep. in 2008 to that in 2012?
Your answer should be very brief. 0.85. What is the ratio of the Imports (BoP, current US$) in Kiribati in 2009 to that in 2010?
Make the answer very short. 0.92. What is the ratio of the Imports (BoP, current US$) in New Caledonia in 2009 to that in 2010?
Provide a succinct answer. 0.78. What is the ratio of the Imports (BoP, current US$) in Pakistan in 2009 to that in 2010?
Your response must be concise. 0.88. What is the ratio of the Imports (BoP, current US$) of Yemen, Rep. in 2009 to that in 2010?
Keep it short and to the point. 0.94. What is the ratio of the Imports (BoP, current US$) of Kiribati in 2009 to that in 2011?
Give a very brief answer. 0.74. What is the ratio of the Imports (BoP, current US$) in New Caledonia in 2009 to that in 2011?
Ensure brevity in your answer.  0.71. What is the ratio of the Imports (BoP, current US$) of Pakistan in 2009 to that in 2011?
Your answer should be compact. 0.75. What is the ratio of the Imports (BoP, current US$) in Yemen, Rep. in 2009 to that in 2011?
Your answer should be compact. 0.93. What is the ratio of the Imports (BoP, current US$) in Kiribati in 2009 to that in 2012?
Keep it short and to the point. 0.64. What is the ratio of the Imports (BoP, current US$) in New Caledonia in 2009 to that in 2012?
Your response must be concise. 0.75. What is the ratio of the Imports (BoP, current US$) in Pakistan in 2009 to that in 2012?
Keep it short and to the point. 0.72. What is the ratio of the Imports (BoP, current US$) in Yemen, Rep. in 2009 to that in 2012?
Provide a succinct answer. 0.73. What is the ratio of the Imports (BoP, current US$) of Kiribati in 2010 to that in 2011?
Your response must be concise. 0.81. What is the ratio of the Imports (BoP, current US$) of New Caledonia in 2010 to that in 2011?
Provide a succinct answer. 0.91. What is the ratio of the Imports (BoP, current US$) in Pakistan in 2010 to that in 2011?
Provide a short and direct response. 0.85. What is the ratio of the Imports (BoP, current US$) of Yemen, Rep. in 2010 to that in 2011?
Your answer should be very brief. 0.99. What is the ratio of the Imports (BoP, current US$) in Kiribati in 2010 to that in 2012?
Keep it short and to the point. 0.7. What is the ratio of the Imports (BoP, current US$) in New Caledonia in 2010 to that in 2012?
Give a very brief answer. 0.96. What is the ratio of the Imports (BoP, current US$) of Pakistan in 2010 to that in 2012?
Provide a short and direct response. 0.82. What is the ratio of the Imports (BoP, current US$) of Yemen, Rep. in 2010 to that in 2012?
Provide a succinct answer. 0.78. What is the ratio of the Imports (BoP, current US$) of Kiribati in 2011 to that in 2012?
Provide a short and direct response. 0.87. What is the ratio of the Imports (BoP, current US$) in New Caledonia in 2011 to that in 2012?
Your answer should be compact. 1.06. What is the ratio of the Imports (BoP, current US$) of Pakistan in 2011 to that in 2012?
Provide a succinct answer. 0.96. What is the ratio of the Imports (BoP, current US$) of Yemen, Rep. in 2011 to that in 2012?
Your answer should be compact. 0.78. What is the difference between the highest and the second highest Imports (BoP, current US$) in Kiribati?
Your answer should be very brief. 2.43e+07. What is the difference between the highest and the second highest Imports (BoP, current US$) of New Caledonia?
Give a very brief answer. 2.77e+08. What is the difference between the highest and the second highest Imports (BoP, current US$) of Pakistan?
Your answer should be very brief. 9.67e+08. What is the difference between the highest and the second highest Imports (BoP, current US$) in Yemen, Rep.?
Make the answer very short. 2.01e+09. What is the difference between the highest and the lowest Imports (BoP, current US$) in Kiribati?
Your answer should be compact. 8.41e+07. What is the difference between the highest and the lowest Imports (BoP, current US$) of New Caledonia?
Your answer should be compact. 1.73e+09. What is the difference between the highest and the lowest Imports (BoP, current US$) of Pakistan?
Provide a succinct answer. 1.38e+1. What is the difference between the highest and the lowest Imports (BoP, current US$) of Yemen, Rep.?
Ensure brevity in your answer.  5.91e+09. 